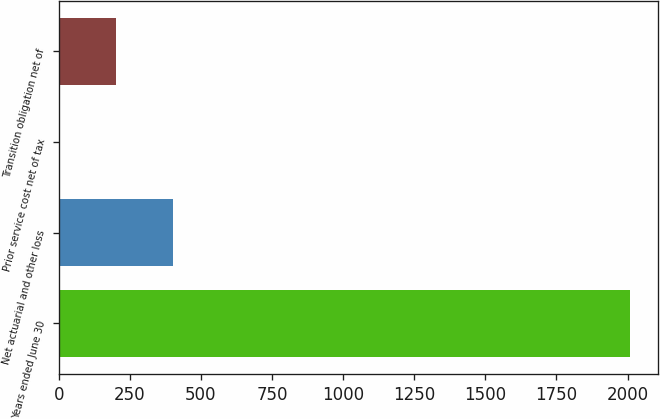Convert chart to OTSL. <chart><loc_0><loc_0><loc_500><loc_500><bar_chart><fcel>Years ended June 30<fcel>Net actuarial and other loss<fcel>Prior service cost net of tax<fcel>Transition obligation net of<nl><fcel>2007<fcel>401.8<fcel>0.5<fcel>201.15<nl></chart> 